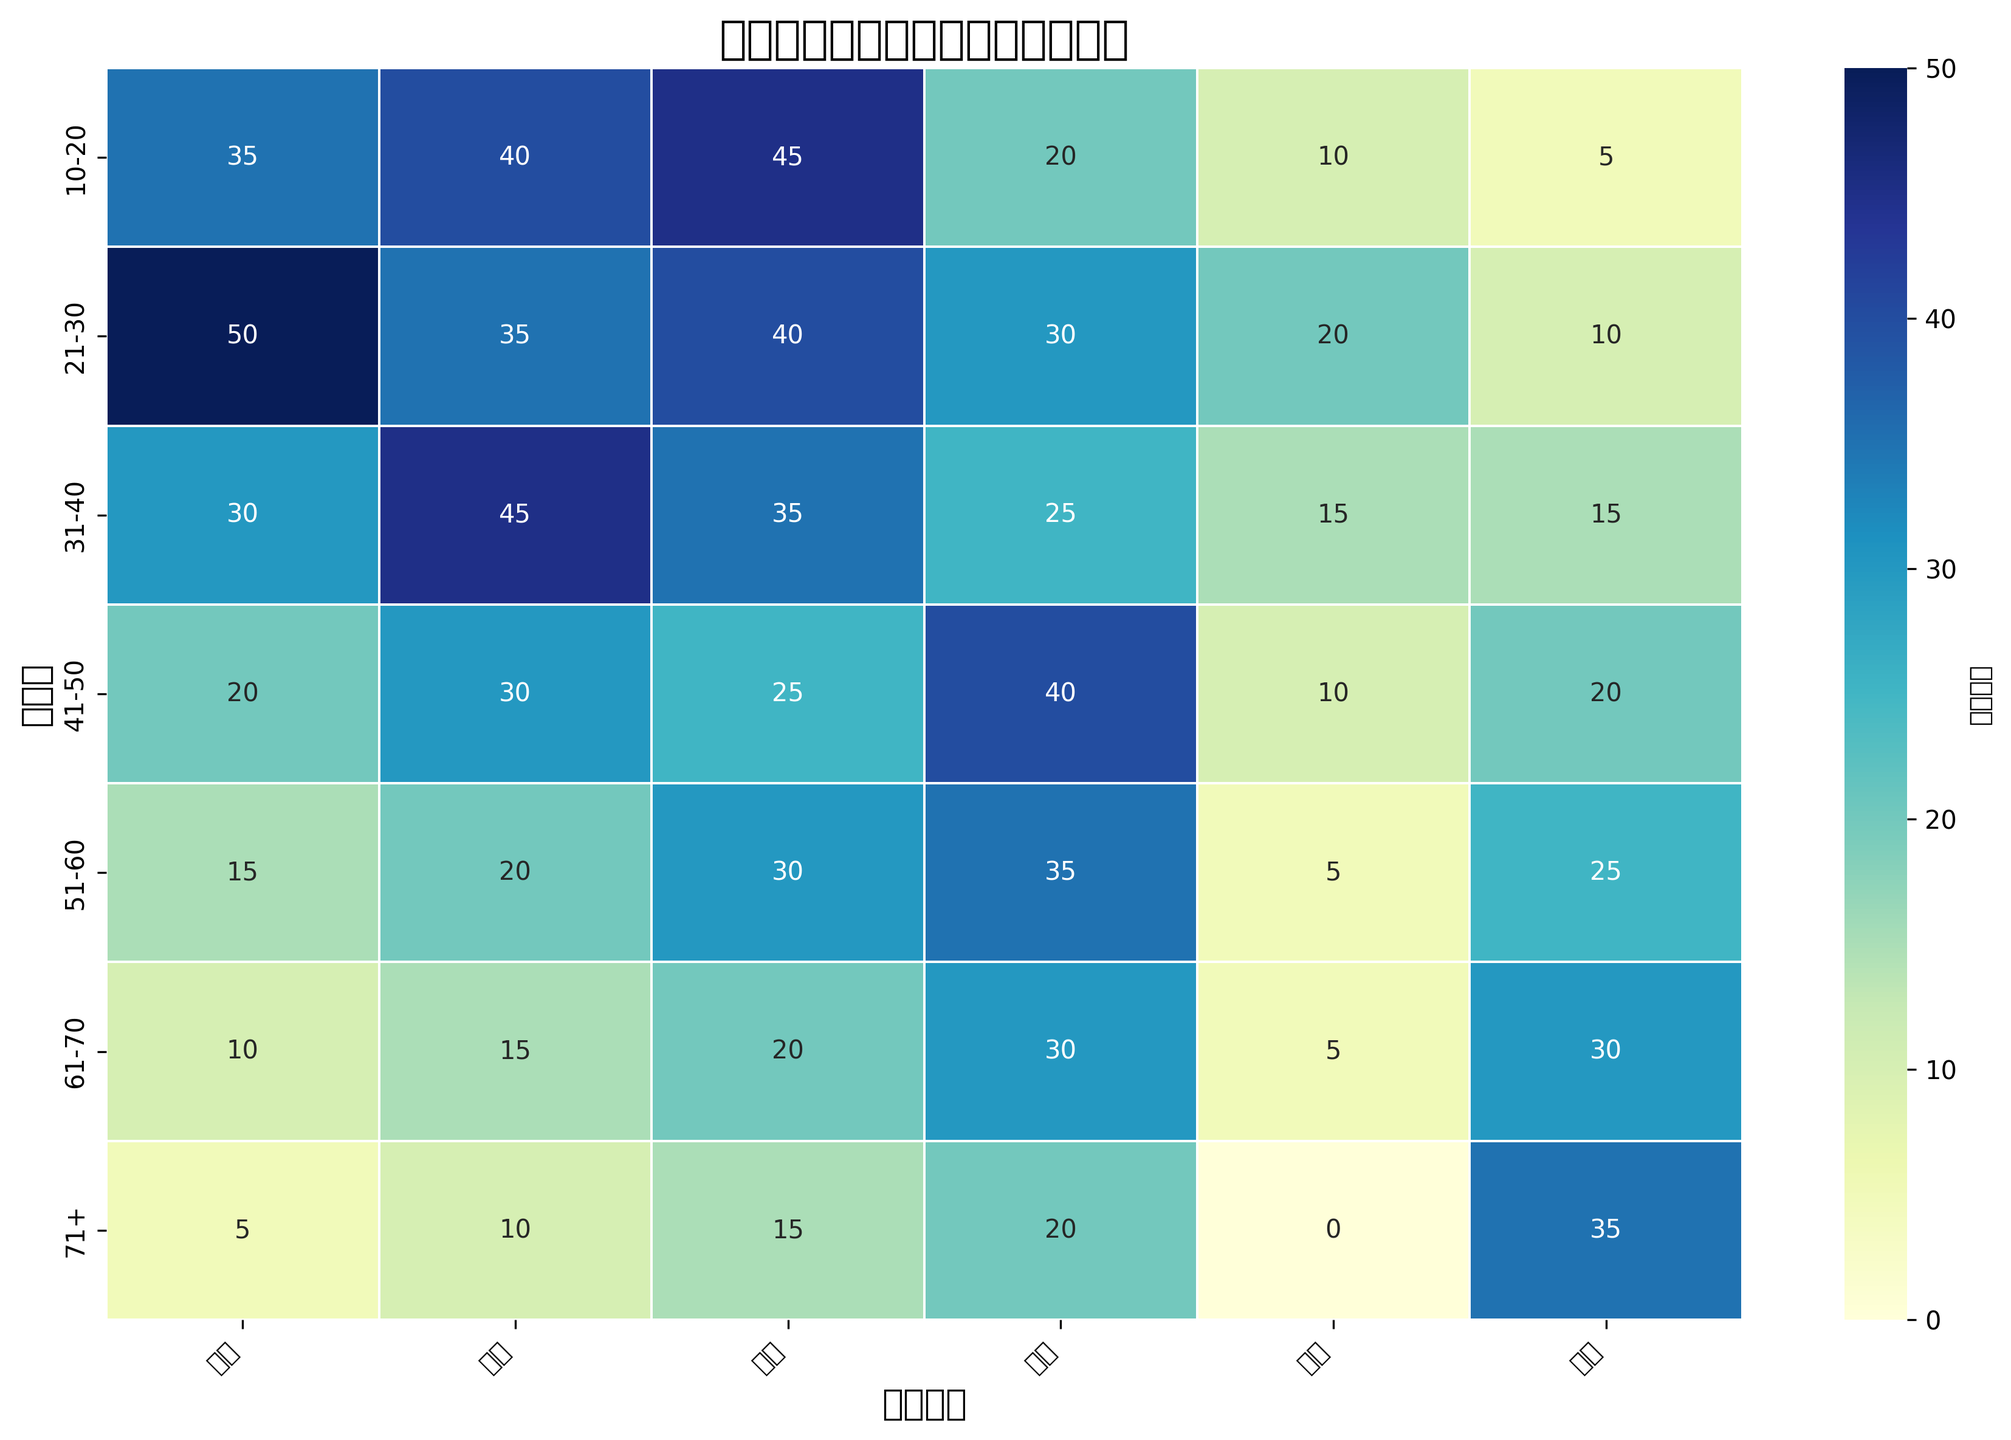哪个年龄段对爱情日剧的偏好最高？ 查看关于“爱情”一列中数值最大的格子，该格子所在的行即对应的年龄段。在这个表格中，“21-30”年龄段的偏好程度是50，是所有年龄段中最高的。
Answer: 21-30 哪个年龄段对恐怖日剧的偏好最低？ 查看关于“恐怖”一列中数值最小的格子，该格子所在的行即对应的年龄段。在这个表格中，“71+”年龄段的偏好程度是0，是所有年龄段中最低的。
Answer: 71+ 比较21-30和31-40年龄段对悬疑日剧的偏好，哪个更高？ 查看关于“悬疑”一列中这两个年龄段的数值。21-30年龄段对悬疑的偏好是35，而31-40年龄段是45，因此31-40年龄段更高。
Answer: 31-40 各年龄段中对科幻日剧的平均偏好度是多少？ 依次查看“科幻”一列，所有数值相加再除以年龄段的数量。具体步骤是：(10 + 20 + 15 + 10 + 5 + 5 + 0) / 7 = 65 / 7 ≈ 9.29
Answer: 9.29 31-40年龄段对各类日剧的总偏好程度是多少？ 对“31-40”这一行的所有数值进行求和。具体步骤是：30 + 45 + 35 + 25 + 15 + 15 = 165
Answer: 165 哪个日剧类型在所有年龄段中最受欢迎？ 查看每列中的最大数值，然后找到所有列中最大的那个数值。这最大数值所在的列即对应的日剧类型。在这里，每列的最大值分别是爱情：50，悬疑：45，喜剧：45，动作：40，科幻：20，恐怖：35。其中最大的是爱情的50。
Answer: 爱情 哪个年龄段对动作日剧和恐怖日剧的总偏好最低？ 对每行中的动作和恐怖数值进行相加，然后比较所有列的结果。具体步骤是找到每行动作和恐怖的数值之和，再比较所有行的和。结果如下：10-20：25，21-30：40，31-40：40，41-50：60，51-60：60，61-70：60，71+：55。从中可以看到10-20年龄段的最小，总和为25。
Answer: 10-20 哪些年龄段对喜剧日剧的偏好大于40？ 查看“喜剧”一栏中超过40的格子，并找到这些格子对应的行。在此数据中，10-20和21-30这两个年龄段的数值分别是45和40。尽管21-30是等于而非大于，但10-20超过了40。
Answer: 10-20 哪个年龄段对所有日剧类型的偏好最低？ 对每一行的数值进行求和，找到所有行中和最小的那一行。在此数据中，总和最小的是“71+”：5 + 10 + 15 + 20 + 0 + 35 = 85。
Answer: 71+ 